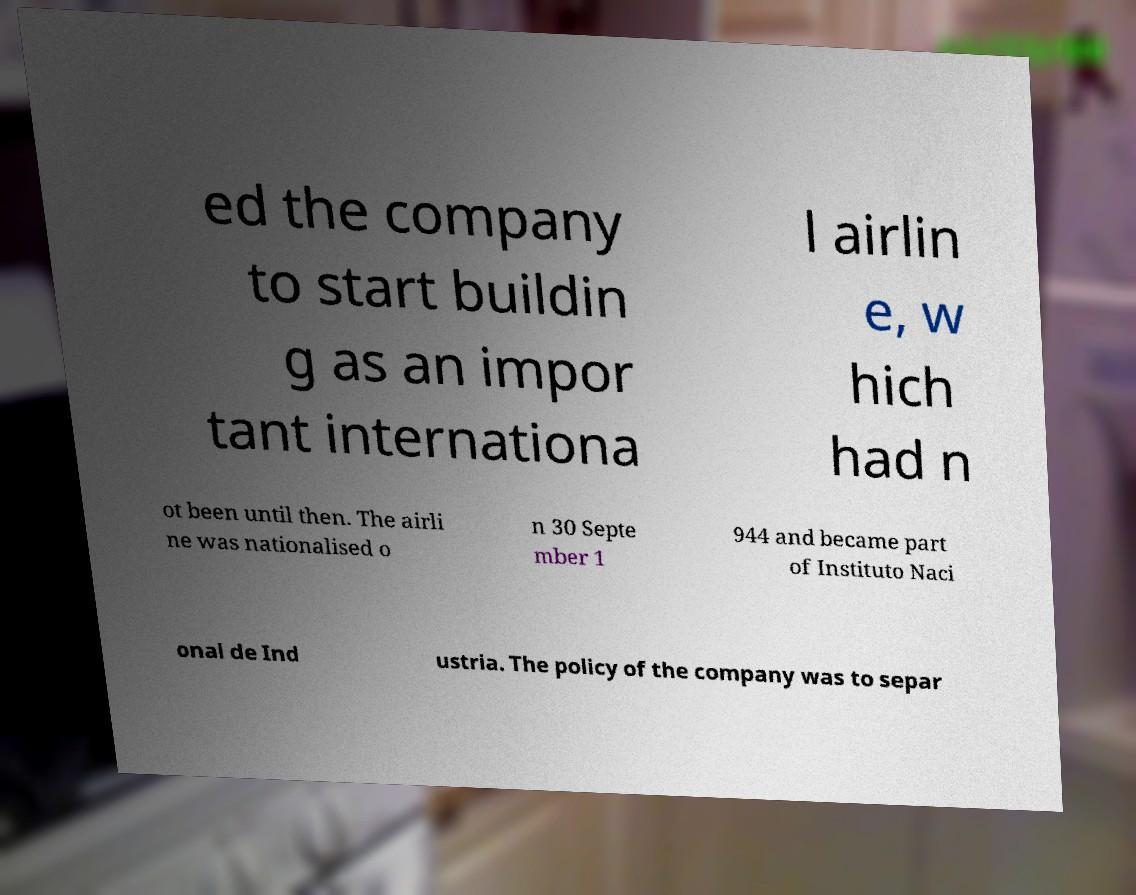Can you accurately transcribe the text from the provided image for me? ed the company to start buildin g as an impor tant internationa l airlin e, w hich had n ot been until then. The airli ne was nationalised o n 30 Septe mber 1 944 and became part of Instituto Naci onal de Ind ustria. The policy of the company was to separ 